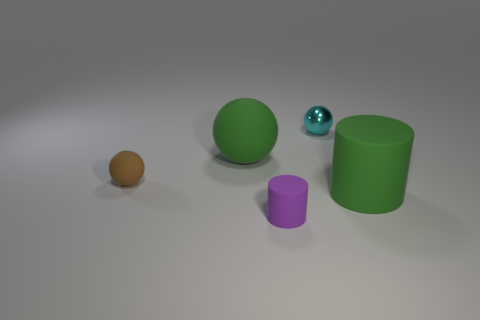Is there anything else that has the same material as the tiny cyan ball?
Keep it short and to the point. No. What is the shape of the matte thing that is the same color as the big ball?
Ensure brevity in your answer.  Cylinder. There is a big green object that is to the left of the tiny cyan metallic ball; what shape is it?
Your response must be concise. Sphere. Are there any big objects of the same color as the large ball?
Ensure brevity in your answer.  Yes. How many other things are the same material as the brown thing?
Offer a very short reply. 3. Are there the same number of cyan objects that are in front of the small cyan object and tiny blue cylinders?
Provide a succinct answer. Yes. There is a small thing to the right of the rubber cylinder that is in front of the big green matte thing that is on the right side of the large ball; what is it made of?
Your answer should be very brief. Metal. What is the color of the matte cylinder on the left side of the cyan ball?
Your answer should be very brief. Purple. There is a sphere left of the large rubber object that is left of the small cyan metal sphere; what is its size?
Offer a terse response. Small. Are there an equal number of small rubber cylinders that are behind the large sphere and cylinders that are behind the cyan sphere?
Keep it short and to the point. Yes. 